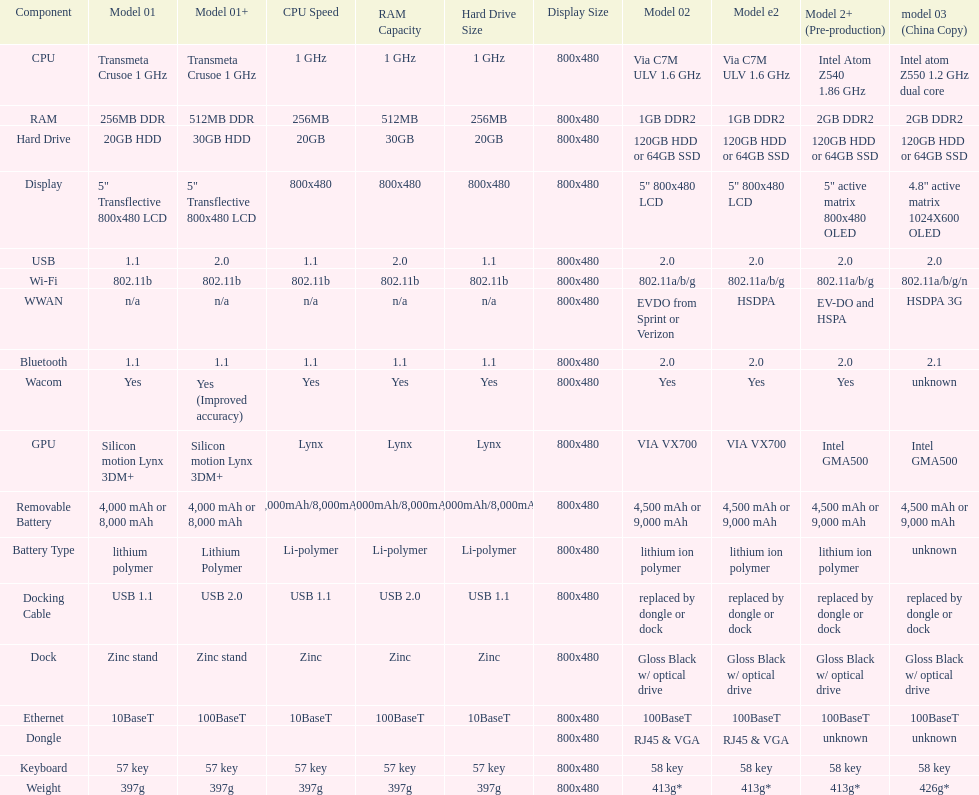How much more weight does the model 3 have over model 1? 29g. 